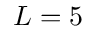<formula> <loc_0><loc_0><loc_500><loc_500>L = 5</formula> 